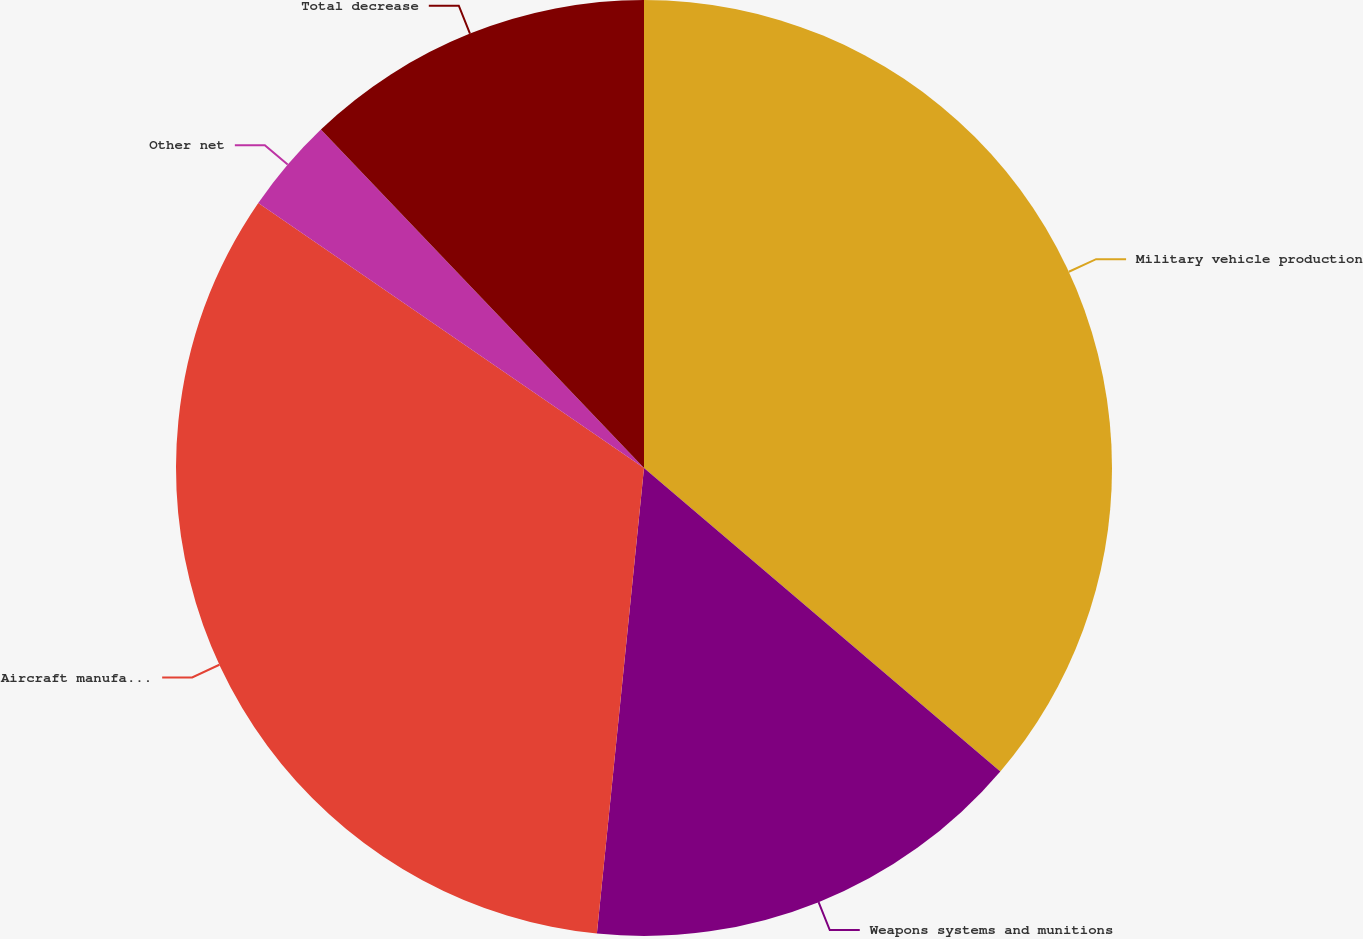Convert chart to OTSL. <chart><loc_0><loc_0><loc_500><loc_500><pie_chart><fcel>Military vehicle production<fcel>Weapons systems and munitions<fcel>Aircraft manufacturing and<fcel>Other net<fcel>Total decrease<nl><fcel>36.23%<fcel>15.38%<fcel>32.98%<fcel>3.29%<fcel>12.13%<nl></chart> 